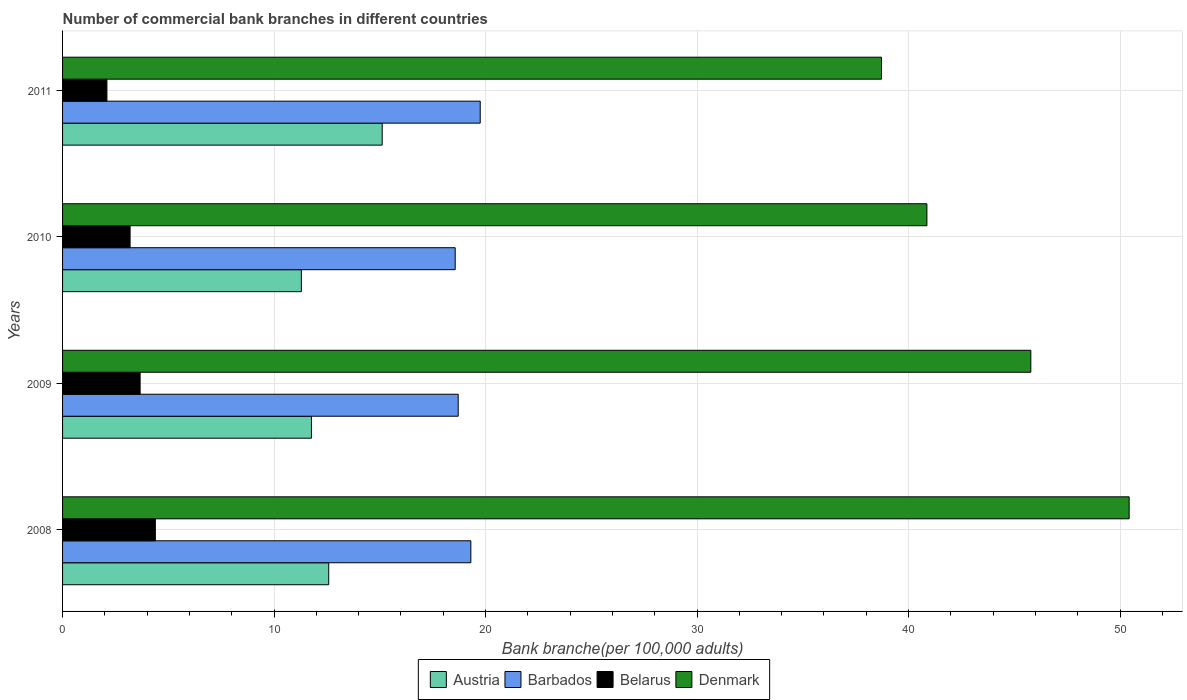Are the number of bars on each tick of the Y-axis equal?
Ensure brevity in your answer.  Yes. How many bars are there on the 1st tick from the top?
Your response must be concise. 4. How many bars are there on the 2nd tick from the bottom?
Your answer should be compact. 4. In how many cases, is the number of bars for a given year not equal to the number of legend labels?
Offer a terse response. 0. What is the number of commercial bank branches in Denmark in 2009?
Provide a succinct answer. 45.78. Across all years, what is the maximum number of commercial bank branches in Belarus?
Your response must be concise. 4.39. Across all years, what is the minimum number of commercial bank branches in Belarus?
Offer a terse response. 2.1. What is the total number of commercial bank branches in Belarus in the graph?
Ensure brevity in your answer.  13.35. What is the difference between the number of commercial bank branches in Austria in 2009 and that in 2011?
Make the answer very short. -3.35. What is the difference between the number of commercial bank branches in Denmark in 2010 and the number of commercial bank branches in Austria in 2009?
Give a very brief answer. 29.1. What is the average number of commercial bank branches in Barbados per year?
Ensure brevity in your answer.  19.08. In the year 2011, what is the difference between the number of commercial bank branches in Barbados and number of commercial bank branches in Belarus?
Keep it short and to the point. 17.65. In how many years, is the number of commercial bank branches in Denmark greater than 12 ?
Give a very brief answer. 4. What is the ratio of the number of commercial bank branches in Denmark in 2010 to that in 2011?
Provide a succinct answer. 1.06. Is the number of commercial bank branches in Barbados in 2010 less than that in 2011?
Offer a terse response. Yes. What is the difference between the highest and the second highest number of commercial bank branches in Denmark?
Offer a terse response. 4.65. What is the difference between the highest and the lowest number of commercial bank branches in Belarus?
Offer a terse response. 2.29. Is the sum of the number of commercial bank branches in Belarus in 2008 and 2009 greater than the maximum number of commercial bank branches in Austria across all years?
Provide a short and direct response. No. What does the 4th bar from the top in 2008 represents?
Provide a succinct answer. Austria. What does the 1st bar from the bottom in 2011 represents?
Ensure brevity in your answer.  Austria. What is the difference between two consecutive major ticks on the X-axis?
Ensure brevity in your answer.  10. Does the graph contain any zero values?
Offer a very short reply. No. How many legend labels are there?
Your answer should be very brief. 4. How are the legend labels stacked?
Provide a succinct answer. Horizontal. What is the title of the graph?
Ensure brevity in your answer.  Number of commercial bank branches in different countries. Does "Caribbean small states" appear as one of the legend labels in the graph?
Ensure brevity in your answer.  No. What is the label or title of the X-axis?
Your response must be concise. Bank branche(per 100,0 adults). What is the Bank branche(per 100,000 adults) of Austria in 2008?
Ensure brevity in your answer.  12.58. What is the Bank branche(per 100,000 adults) of Barbados in 2008?
Give a very brief answer. 19.3. What is the Bank branche(per 100,000 adults) of Belarus in 2008?
Your answer should be very brief. 4.39. What is the Bank branche(per 100,000 adults) in Denmark in 2008?
Keep it short and to the point. 50.43. What is the Bank branche(per 100,000 adults) of Austria in 2009?
Ensure brevity in your answer.  11.77. What is the Bank branche(per 100,000 adults) of Barbados in 2009?
Your answer should be compact. 18.71. What is the Bank branche(per 100,000 adults) of Belarus in 2009?
Keep it short and to the point. 3.67. What is the Bank branche(per 100,000 adults) in Denmark in 2009?
Your response must be concise. 45.78. What is the Bank branche(per 100,000 adults) of Austria in 2010?
Offer a terse response. 11.29. What is the Bank branche(per 100,000 adults) in Barbados in 2010?
Your response must be concise. 18.56. What is the Bank branche(per 100,000 adults) in Belarus in 2010?
Ensure brevity in your answer.  3.19. What is the Bank branche(per 100,000 adults) of Denmark in 2010?
Ensure brevity in your answer.  40.87. What is the Bank branche(per 100,000 adults) in Austria in 2011?
Keep it short and to the point. 15.11. What is the Bank branche(per 100,000 adults) in Barbados in 2011?
Give a very brief answer. 19.75. What is the Bank branche(per 100,000 adults) of Belarus in 2011?
Offer a very short reply. 2.1. What is the Bank branche(per 100,000 adults) in Denmark in 2011?
Ensure brevity in your answer.  38.72. Across all years, what is the maximum Bank branche(per 100,000 adults) in Austria?
Your answer should be compact. 15.11. Across all years, what is the maximum Bank branche(per 100,000 adults) in Barbados?
Offer a terse response. 19.75. Across all years, what is the maximum Bank branche(per 100,000 adults) of Belarus?
Give a very brief answer. 4.39. Across all years, what is the maximum Bank branche(per 100,000 adults) of Denmark?
Ensure brevity in your answer.  50.43. Across all years, what is the minimum Bank branche(per 100,000 adults) in Austria?
Your answer should be very brief. 11.29. Across all years, what is the minimum Bank branche(per 100,000 adults) of Barbados?
Your answer should be compact. 18.56. Across all years, what is the minimum Bank branche(per 100,000 adults) in Belarus?
Ensure brevity in your answer.  2.1. Across all years, what is the minimum Bank branche(per 100,000 adults) of Denmark?
Offer a terse response. 38.72. What is the total Bank branche(per 100,000 adults) in Austria in the graph?
Offer a very short reply. 50.76. What is the total Bank branche(per 100,000 adults) of Barbados in the graph?
Give a very brief answer. 76.32. What is the total Bank branche(per 100,000 adults) in Belarus in the graph?
Your response must be concise. 13.35. What is the total Bank branche(per 100,000 adults) of Denmark in the graph?
Give a very brief answer. 175.8. What is the difference between the Bank branche(per 100,000 adults) in Austria in 2008 and that in 2009?
Ensure brevity in your answer.  0.82. What is the difference between the Bank branche(per 100,000 adults) in Barbados in 2008 and that in 2009?
Provide a short and direct response. 0.6. What is the difference between the Bank branche(per 100,000 adults) of Belarus in 2008 and that in 2009?
Give a very brief answer. 0.72. What is the difference between the Bank branche(per 100,000 adults) of Denmark in 2008 and that in 2009?
Keep it short and to the point. 4.65. What is the difference between the Bank branche(per 100,000 adults) of Austria in 2008 and that in 2010?
Offer a terse response. 1.29. What is the difference between the Bank branche(per 100,000 adults) of Barbados in 2008 and that in 2010?
Provide a short and direct response. 0.74. What is the difference between the Bank branche(per 100,000 adults) of Belarus in 2008 and that in 2010?
Keep it short and to the point. 1.19. What is the difference between the Bank branche(per 100,000 adults) in Denmark in 2008 and that in 2010?
Ensure brevity in your answer.  9.56. What is the difference between the Bank branche(per 100,000 adults) of Austria in 2008 and that in 2011?
Your response must be concise. -2.53. What is the difference between the Bank branche(per 100,000 adults) of Barbados in 2008 and that in 2011?
Ensure brevity in your answer.  -0.44. What is the difference between the Bank branche(per 100,000 adults) of Belarus in 2008 and that in 2011?
Ensure brevity in your answer.  2.29. What is the difference between the Bank branche(per 100,000 adults) of Denmark in 2008 and that in 2011?
Keep it short and to the point. 11.71. What is the difference between the Bank branche(per 100,000 adults) in Austria in 2009 and that in 2010?
Give a very brief answer. 0.48. What is the difference between the Bank branche(per 100,000 adults) of Barbados in 2009 and that in 2010?
Provide a succinct answer. 0.14. What is the difference between the Bank branche(per 100,000 adults) of Belarus in 2009 and that in 2010?
Keep it short and to the point. 0.47. What is the difference between the Bank branche(per 100,000 adults) in Denmark in 2009 and that in 2010?
Provide a succinct answer. 4.91. What is the difference between the Bank branche(per 100,000 adults) in Austria in 2009 and that in 2011?
Keep it short and to the point. -3.35. What is the difference between the Bank branche(per 100,000 adults) in Barbados in 2009 and that in 2011?
Your answer should be very brief. -1.04. What is the difference between the Bank branche(per 100,000 adults) in Belarus in 2009 and that in 2011?
Provide a short and direct response. 1.57. What is the difference between the Bank branche(per 100,000 adults) in Denmark in 2009 and that in 2011?
Provide a short and direct response. 7.06. What is the difference between the Bank branche(per 100,000 adults) of Austria in 2010 and that in 2011?
Keep it short and to the point. -3.82. What is the difference between the Bank branche(per 100,000 adults) in Barbados in 2010 and that in 2011?
Make the answer very short. -1.18. What is the difference between the Bank branche(per 100,000 adults) of Belarus in 2010 and that in 2011?
Offer a very short reply. 1.1. What is the difference between the Bank branche(per 100,000 adults) in Denmark in 2010 and that in 2011?
Give a very brief answer. 2.15. What is the difference between the Bank branche(per 100,000 adults) in Austria in 2008 and the Bank branche(per 100,000 adults) in Barbados in 2009?
Keep it short and to the point. -6.12. What is the difference between the Bank branche(per 100,000 adults) in Austria in 2008 and the Bank branche(per 100,000 adults) in Belarus in 2009?
Keep it short and to the point. 8.92. What is the difference between the Bank branche(per 100,000 adults) in Austria in 2008 and the Bank branche(per 100,000 adults) in Denmark in 2009?
Ensure brevity in your answer.  -33.2. What is the difference between the Bank branche(per 100,000 adults) of Barbados in 2008 and the Bank branche(per 100,000 adults) of Belarus in 2009?
Offer a terse response. 15.64. What is the difference between the Bank branche(per 100,000 adults) of Barbados in 2008 and the Bank branche(per 100,000 adults) of Denmark in 2009?
Offer a terse response. -26.48. What is the difference between the Bank branche(per 100,000 adults) in Belarus in 2008 and the Bank branche(per 100,000 adults) in Denmark in 2009?
Make the answer very short. -41.39. What is the difference between the Bank branche(per 100,000 adults) in Austria in 2008 and the Bank branche(per 100,000 adults) in Barbados in 2010?
Make the answer very short. -5.98. What is the difference between the Bank branche(per 100,000 adults) in Austria in 2008 and the Bank branche(per 100,000 adults) in Belarus in 2010?
Your answer should be very brief. 9.39. What is the difference between the Bank branche(per 100,000 adults) of Austria in 2008 and the Bank branche(per 100,000 adults) of Denmark in 2010?
Offer a very short reply. -28.28. What is the difference between the Bank branche(per 100,000 adults) in Barbados in 2008 and the Bank branche(per 100,000 adults) in Belarus in 2010?
Your answer should be very brief. 16.11. What is the difference between the Bank branche(per 100,000 adults) in Barbados in 2008 and the Bank branche(per 100,000 adults) in Denmark in 2010?
Give a very brief answer. -21.56. What is the difference between the Bank branche(per 100,000 adults) of Belarus in 2008 and the Bank branche(per 100,000 adults) of Denmark in 2010?
Keep it short and to the point. -36.48. What is the difference between the Bank branche(per 100,000 adults) in Austria in 2008 and the Bank branche(per 100,000 adults) in Barbados in 2011?
Make the answer very short. -7.16. What is the difference between the Bank branche(per 100,000 adults) in Austria in 2008 and the Bank branche(per 100,000 adults) in Belarus in 2011?
Ensure brevity in your answer.  10.49. What is the difference between the Bank branche(per 100,000 adults) in Austria in 2008 and the Bank branche(per 100,000 adults) in Denmark in 2011?
Keep it short and to the point. -26.14. What is the difference between the Bank branche(per 100,000 adults) of Barbados in 2008 and the Bank branche(per 100,000 adults) of Belarus in 2011?
Offer a terse response. 17.21. What is the difference between the Bank branche(per 100,000 adults) of Barbados in 2008 and the Bank branche(per 100,000 adults) of Denmark in 2011?
Ensure brevity in your answer.  -19.42. What is the difference between the Bank branche(per 100,000 adults) in Belarus in 2008 and the Bank branche(per 100,000 adults) in Denmark in 2011?
Your response must be concise. -34.33. What is the difference between the Bank branche(per 100,000 adults) of Austria in 2009 and the Bank branche(per 100,000 adults) of Barbados in 2010?
Your answer should be compact. -6.8. What is the difference between the Bank branche(per 100,000 adults) in Austria in 2009 and the Bank branche(per 100,000 adults) in Belarus in 2010?
Ensure brevity in your answer.  8.57. What is the difference between the Bank branche(per 100,000 adults) of Austria in 2009 and the Bank branche(per 100,000 adults) of Denmark in 2010?
Your answer should be very brief. -29.1. What is the difference between the Bank branche(per 100,000 adults) of Barbados in 2009 and the Bank branche(per 100,000 adults) of Belarus in 2010?
Give a very brief answer. 15.51. What is the difference between the Bank branche(per 100,000 adults) of Barbados in 2009 and the Bank branche(per 100,000 adults) of Denmark in 2010?
Provide a succinct answer. -22.16. What is the difference between the Bank branche(per 100,000 adults) in Belarus in 2009 and the Bank branche(per 100,000 adults) in Denmark in 2010?
Provide a succinct answer. -37.2. What is the difference between the Bank branche(per 100,000 adults) of Austria in 2009 and the Bank branche(per 100,000 adults) of Barbados in 2011?
Your answer should be very brief. -7.98. What is the difference between the Bank branche(per 100,000 adults) of Austria in 2009 and the Bank branche(per 100,000 adults) of Belarus in 2011?
Ensure brevity in your answer.  9.67. What is the difference between the Bank branche(per 100,000 adults) in Austria in 2009 and the Bank branche(per 100,000 adults) in Denmark in 2011?
Give a very brief answer. -26.95. What is the difference between the Bank branche(per 100,000 adults) of Barbados in 2009 and the Bank branche(per 100,000 adults) of Belarus in 2011?
Offer a very short reply. 16.61. What is the difference between the Bank branche(per 100,000 adults) of Barbados in 2009 and the Bank branche(per 100,000 adults) of Denmark in 2011?
Make the answer very short. -20.02. What is the difference between the Bank branche(per 100,000 adults) of Belarus in 2009 and the Bank branche(per 100,000 adults) of Denmark in 2011?
Keep it short and to the point. -35.05. What is the difference between the Bank branche(per 100,000 adults) in Austria in 2010 and the Bank branche(per 100,000 adults) in Barbados in 2011?
Make the answer very short. -8.46. What is the difference between the Bank branche(per 100,000 adults) in Austria in 2010 and the Bank branche(per 100,000 adults) in Belarus in 2011?
Provide a short and direct response. 9.19. What is the difference between the Bank branche(per 100,000 adults) in Austria in 2010 and the Bank branche(per 100,000 adults) in Denmark in 2011?
Offer a very short reply. -27.43. What is the difference between the Bank branche(per 100,000 adults) of Barbados in 2010 and the Bank branche(per 100,000 adults) of Belarus in 2011?
Your answer should be very brief. 16.47. What is the difference between the Bank branche(per 100,000 adults) in Barbados in 2010 and the Bank branche(per 100,000 adults) in Denmark in 2011?
Offer a very short reply. -20.16. What is the difference between the Bank branche(per 100,000 adults) of Belarus in 2010 and the Bank branche(per 100,000 adults) of Denmark in 2011?
Your answer should be very brief. -35.53. What is the average Bank branche(per 100,000 adults) in Austria per year?
Your answer should be compact. 12.69. What is the average Bank branche(per 100,000 adults) in Barbados per year?
Keep it short and to the point. 19.08. What is the average Bank branche(per 100,000 adults) in Belarus per year?
Your response must be concise. 3.34. What is the average Bank branche(per 100,000 adults) of Denmark per year?
Give a very brief answer. 43.95. In the year 2008, what is the difference between the Bank branche(per 100,000 adults) in Austria and Bank branche(per 100,000 adults) in Barbados?
Your response must be concise. -6.72. In the year 2008, what is the difference between the Bank branche(per 100,000 adults) of Austria and Bank branche(per 100,000 adults) of Belarus?
Provide a short and direct response. 8.2. In the year 2008, what is the difference between the Bank branche(per 100,000 adults) of Austria and Bank branche(per 100,000 adults) of Denmark?
Offer a very short reply. -37.85. In the year 2008, what is the difference between the Bank branche(per 100,000 adults) in Barbados and Bank branche(per 100,000 adults) in Belarus?
Ensure brevity in your answer.  14.92. In the year 2008, what is the difference between the Bank branche(per 100,000 adults) of Barbados and Bank branche(per 100,000 adults) of Denmark?
Offer a terse response. -31.13. In the year 2008, what is the difference between the Bank branche(per 100,000 adults) of Belarus and Bank branche(per 100,000 adults) of Denmark?
Your answer should be very brief. -46.04. In the year 2009, what is the difference between the Bank branche(per 100,000 adults) in Austria and Bank branche(per 100,000 adults) in Barbados?
Ensure brevity in your answer.  -6.94. In the year 2009, what is the difference between the Bank branche(per 100,000 adults) in Austria and Bank branche(per 100,000 adults) in Belarus?
Ensure brevity in your answer.  8.1. In the year 2009, what is the difference between the Bank branche(per 100,000 adults) in Austria and Bank branche(per 100,000 adults) in Denmark?
Your answer should be very brief. -34.01. In the year 2009, what is the difference between the Bank branche(per 100,000 adults) in Barbados and Bank branche(per 100,000 adults) in Belarus?
Make the answer very short. 15.04. In the year 2009, what is the difference between the Bank branche(per 100,000 adults) in Barbados and Bank branche(per 100,000 adults) in Denmark?
Your response must be concise. -27.08. In the year 2009, what is the difference between the Bank branche(per 100,000 adults) of Belarus and Bank branche(per 100,000 adults) of Denmark?
Provide a short and direct response. -42.11. In the year 2010, what is the difference between the Bank branche(per 100,000 adults) of Austria and Bank branche(per 100,000 adults) of Barbados?
Make the answer very short. -7.27. In the year 2010, what is the difference between the Bank branche(per 100,000 adults) in Austria and Bank branche(per 100,000 adults) in Belarus?
Give a very brief answer. 8.1. In the year 2010, what is the difference between the Bank branche(per 100,000 adults) in Austria and Bank branche(per 100,000 adults) in Denmark?
Your answer should be very brief. -29.58. In the year 2010, what is the difference between the Bank branche(per 100,000 adults) in Barbados and Bank branche(per 100,000 adults) in Belarus?
Your response must be concise. 15.37. In the year 2010, what is the difference between the Bank branche(per 100,000 adults) in Barbados and Bank branche(per 100,000 adults) in Denmark?
Offer a terse response. -22.3. In the year 2010, what is the difference between the Bank branche(per 100,000 adults) of Belarus and Bank branche(per 100,000 adults) of Denmark?
Keep it short and to the point. -37.68. In the year 2011, what is the difference between the Bank branche(per 100,000 adults) of Austria and Bank branche(per 100,000 adults) of Barbados?
Your answer should be very brief. -4.63. In the year 2011, what is the difference between the Bank branche(per 100,000 adults) in Austria and Bank branche(per 100,000 adults) in Belarus?
Provide a short and direct response. 13.02. In the year 2011, what is the difference between the Bank branche(per 100,000 adults) in Austria and Bank branche(per 100,000 adults) in Denmark?
Make the answer very short. -23.61. In the year 2011, what is the difference between the Bank branche(per 100,000 adults) in Barbados and Bank branche(per 100,000 adults) in Belarus?
Give a very brief answer. 17.65. In the year 2011, what is the difference between the Bank branche(per 100,000 adults) in Barbados and Bank branche(per 100,000 adults) in Denmark?
Make the answer very short. -18.97. In the year 2011, what is the difference between the Bank branche(per 100,000 adults) of Belarus and Bank branche(per 100,000 adults) of Denmark?
Your answer should be compact. -36.62. What is the ratio of the Bank branche(per 100,000 adults) of Austria in 2008 to that in 2009?
Offer a terse response. 1.07. What is the ratio of the Bank branche(per 100,000 adults) in Barbados in 2008 to that in 2009?
Your answer should be very brief. 1.03. What is the ratio of the Bank branche(per 100,000 adults) of Belarus in 2008 to that in 2009?
Offer a very short reply. 1.2. What is the ratio of the Bank branche(per 100,000 adults) in Denmark in 2008 to that in 2009?
Your answer should be compact. 1.1. What is the ratio of the Bank branche(per 100,000 adults) in Austria in 2008 to that in 2010?
Offer a terse response. 1.11. What is the ratio of the Bank branche(per 100,000 adults) in Barbados in 2008 to that in 2010?
Your response must be concise. 1.04. What is the ratio of the Bank branche(per 100,000 adults) of Belarus in 2008 to that in 2010?
Offer a very short reply. 1.37. What is the ratio of the Bank branche(per 100,000 adults) of Denmark in 2008 to that in 2010?
Provide a succinct answer. 1.23. What is the ratio of the Bank branche(per 100,000 adults) in Austria in 2008 to that in 2011?
Ensure brevity in your answer.  0.83. What is the ratio of the Bank branche(per 100,000 adults) of Barbados in 2008 to that in 2011?
Make the answer very short. 0.98. What is the ratio of the Bank branche(per 100,000 adults) of Belarus in 2008 to that in 2011?
Keep it short and to the point. 2.09. What is the ratio of the Bank branche(per 100,000 adults) of Denmark in 2008 to that in 2011?
Provide a short and direct response. 1.3. What is the ratio of the Bank branche(per 100,000 adults) of Austria in 2009 to that in 2010?
Make the answer very short. 1.04. What is the ratio of the Bank branche(per 100,000 adults) in Barbados in 2009 to that in 2010?
Offer a very short reply. 1.01. What is the ratio of the Bank branche(per 100,000 adults) in Belarus in 2009 to that in 2010?
Make the answer very short. 1.15. What is the ratio of the Bank branche(per 100,000 adults) in Denmark in 2009 to that in 2010?
Ensure brevity in your answer.  1.12. What is the ratio of the Bank branche(per 100,000 adults) in Austria in 2009 to that in 2011?
Your response must be concise. 0.78. What is the ratio of the Bank branche(per 100,000 adults) of Barbados in 2009 to that in 2011?
Make the answer very short. 0.95. What is the ratio of the Bank branche(per 100,000 adults) of Belarus in 2009 to that in 2011?
Make the answer very short. 1.75. What is the ratio of the Bank branche(per 100,000 adults) in Denmark in 2009 to that in 2011?
Your answer should be very brief. 1.18. What is the ratio of the Bank branche(per 100,000 adults) of Austria in 2010 to that in 2011?
Ensure brevity in your answer.  0.75. What is the ratio of the Bank branche(per 100,000 adults) of Barbados in 2010 to that in 2011?
Your answer should be very brief. 0.94. What is the ratio of the Bank branche(per 100,000 adults) in Belarus in 2010 to that in 2011?
Ensure brevity in your answer.  1.52. What is the ratio of the Bank branche(per 100,000 adults) in Denmark in 2010 to that in 2011?
Your answer should be very brief. 1.06. What is the difference between the highest and the second highest Bank branche(per 100,000 adults) in Austria?
Your answer should be very brief. 2.53. What is the difference between the highest and the second highest Bank branche(per 100,000 adults) of Barbados?
Make the answer very short. 0.44. What is the difference between the highest and the second highest Bank branche(per 100,000 adults) in Belarus?
Make the answer very short. 0.72. What is the difference between the highest and the second highest Bank branche(per 100,000 adults) of Denmark?
Make the answer very short. 4.65. What is the difference between the highest and the lowest Bank branche(per 100,000 adults) of Austria?
Give a very brief answer. 3.82. What is the difference between the highest and the lowest Bank branche(per 100,000 adults) of Barbados?
Your answer should be compact. 1.18. What is the difference between the highest and the lowest Bank branche(per 100,000 adults) in Belarus?
Offer a very short reply. 2.29. What is the difference between the highest and the lowest Bank branche(per 100,000 adults) of Denmark?
Provide a short and direct response. 11.71. 